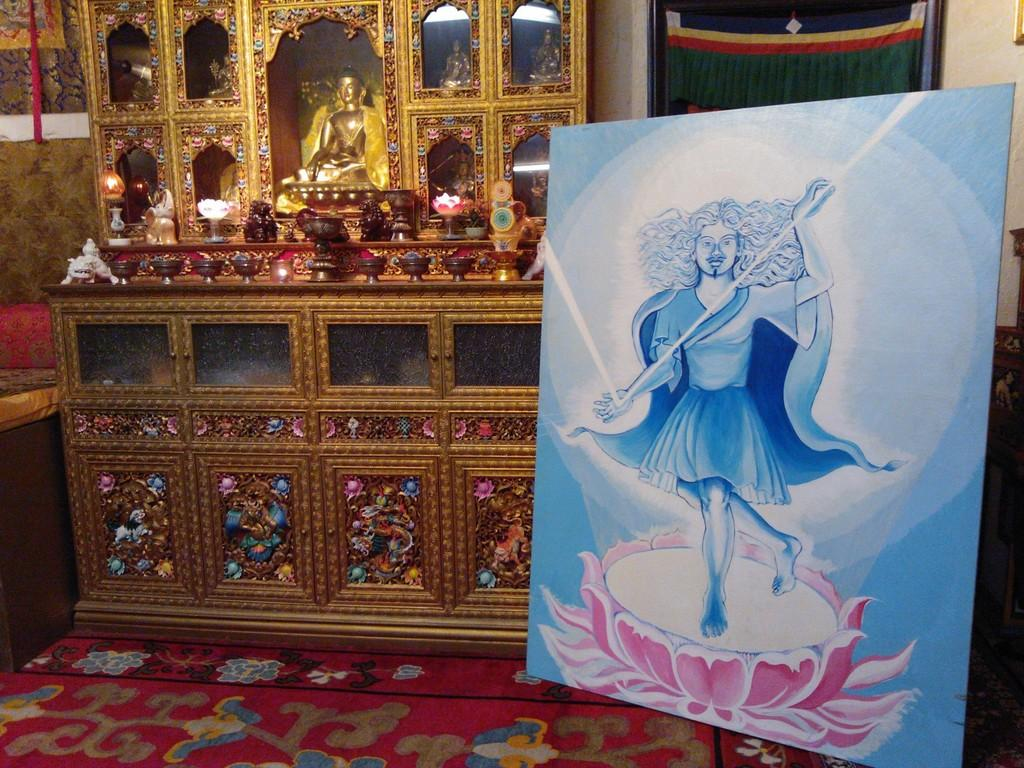What is depicted on the board in the image? There is a painting on a board in the image. What type of floor covering is visible in the image? There is a carpet on the floor in the image. What type of objects can be seen in the image? There are statues in the image. What is the background of the image made of? There is a wall in the image. What type of material is present in the image? There is cloth in the image. Can you describe any other objects in the image? There are other objects in the image. How many flies can be seen on the painting in the image? There are no flies present in the image. What type of quartz is used to create the statues in the image? There is no mention of quartz or any specific material used for the statues in the image. 